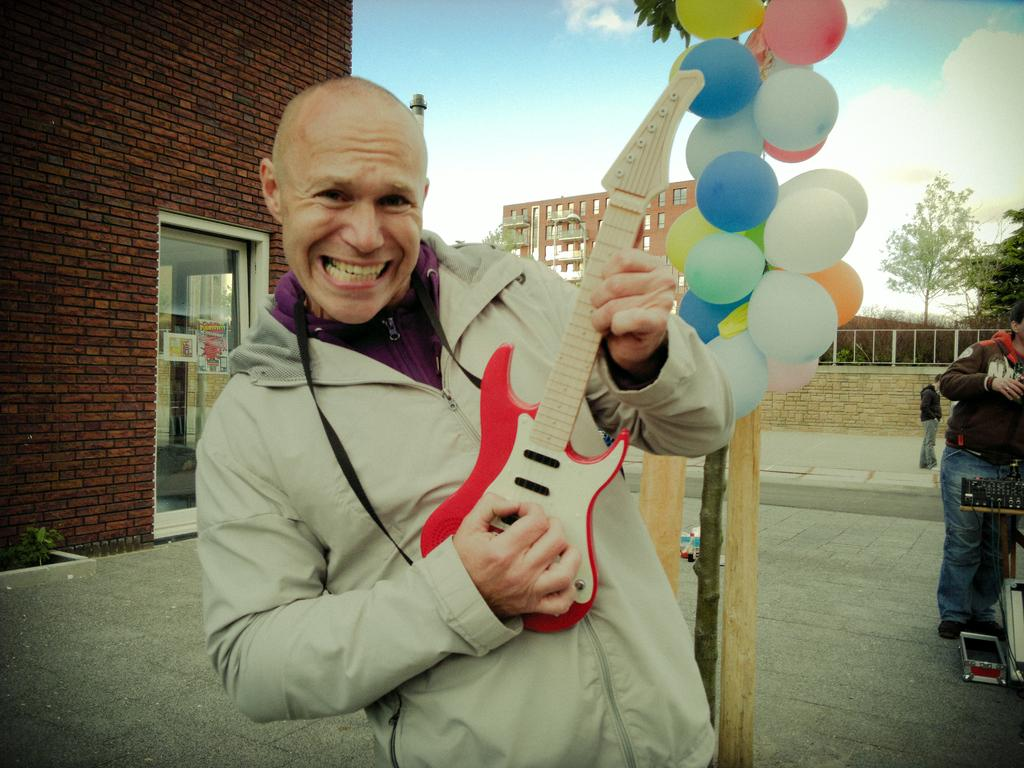What is the person in the image doing? The person is playing a guitar. What else can be seen in the image besides the person playing the guitar? There are balloons and buildings in the image. How many other people are in the image? There are two other persons in the image. What type of horn can be seen in the image? There is no horn present in the image. Where is the wilderness located in the image? There is no wilderness present in the image; it features a person playing a guitar, balloons, buildings, and two other persons. 